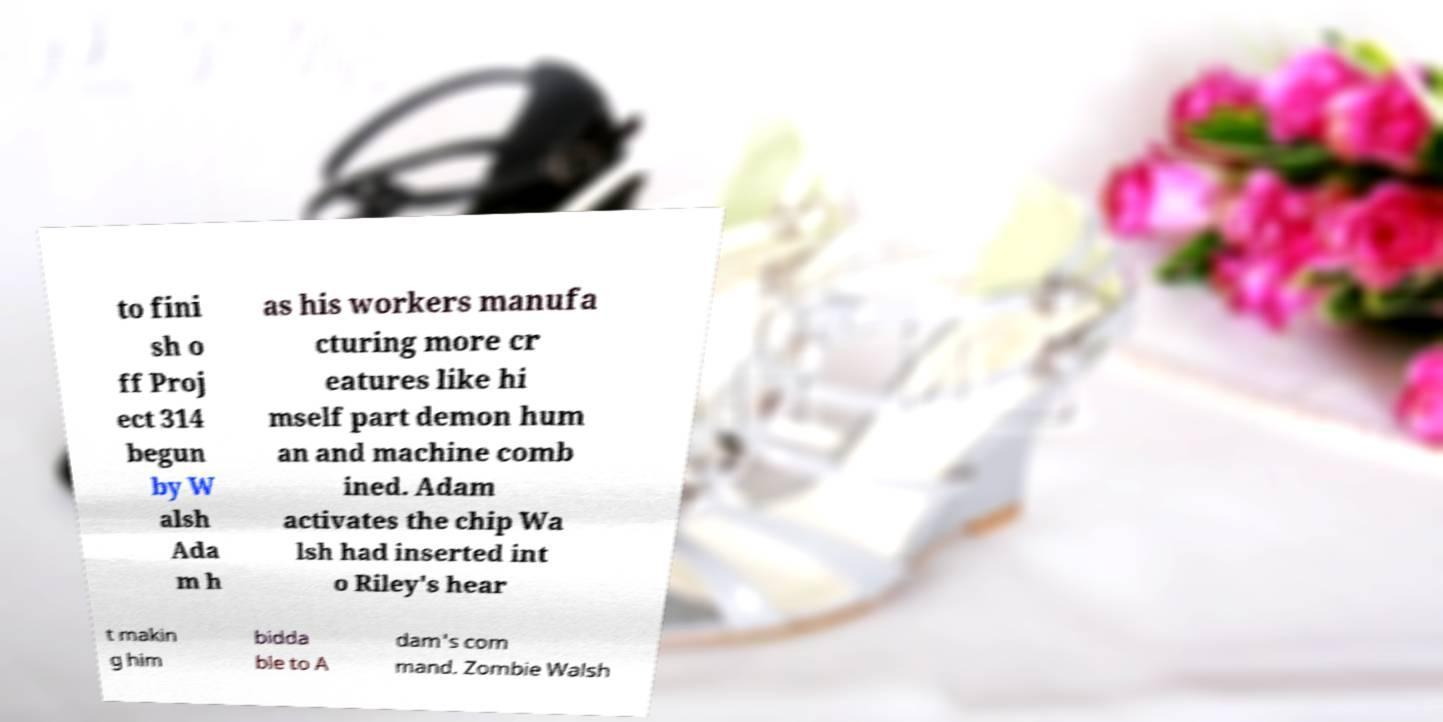What messages or text are displayed in this image? I need them in a readable, typed format. to fini sh o ff Proj ect 314 begun by W alsh Ada m h as his workers manufa cturing more cr eatures like hi mself part demon hum an and machine comb ined. Adam activates the chip Wa lsh had inserted int o Riley's hear t makin g him bidda ble to A dam's com mand. Zombie Walsh 